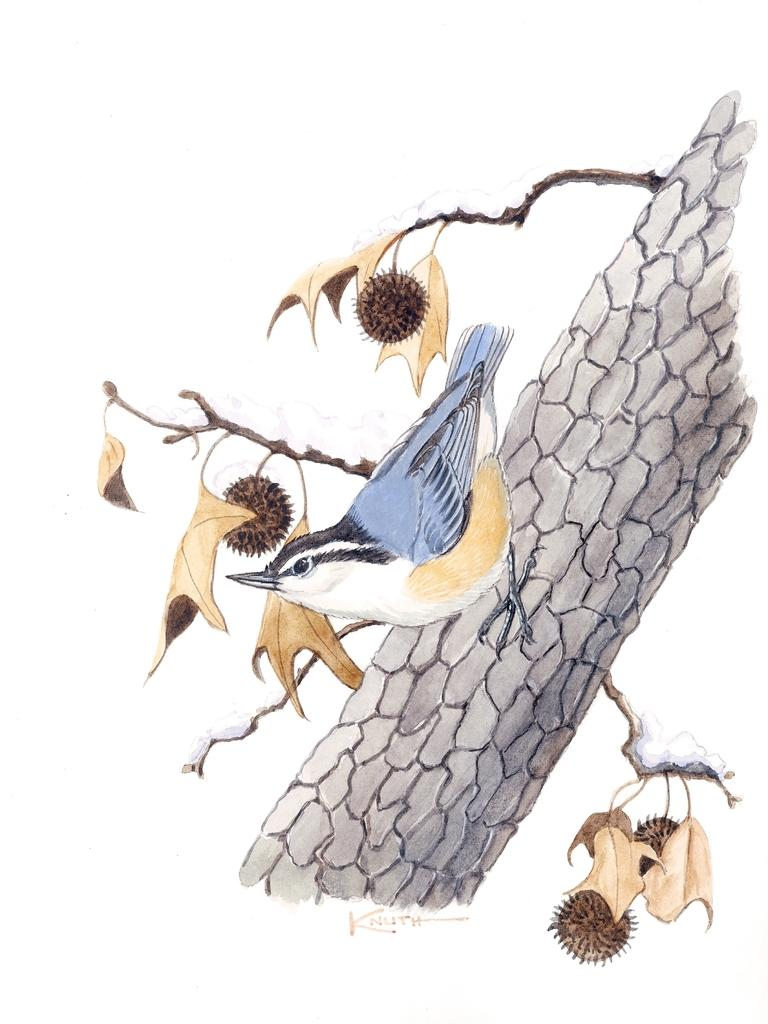What type of artwork is depicted in the image? The image appears to be a painting. What natural element can be seen in the painting? There is a tree in the image. Are there any animals present in the painting? Yes, there is a bird on the tree in the image. What type of nail is being used by the bird in the image? There is no nail present in the image; it is a bird on a tree in a painting. 